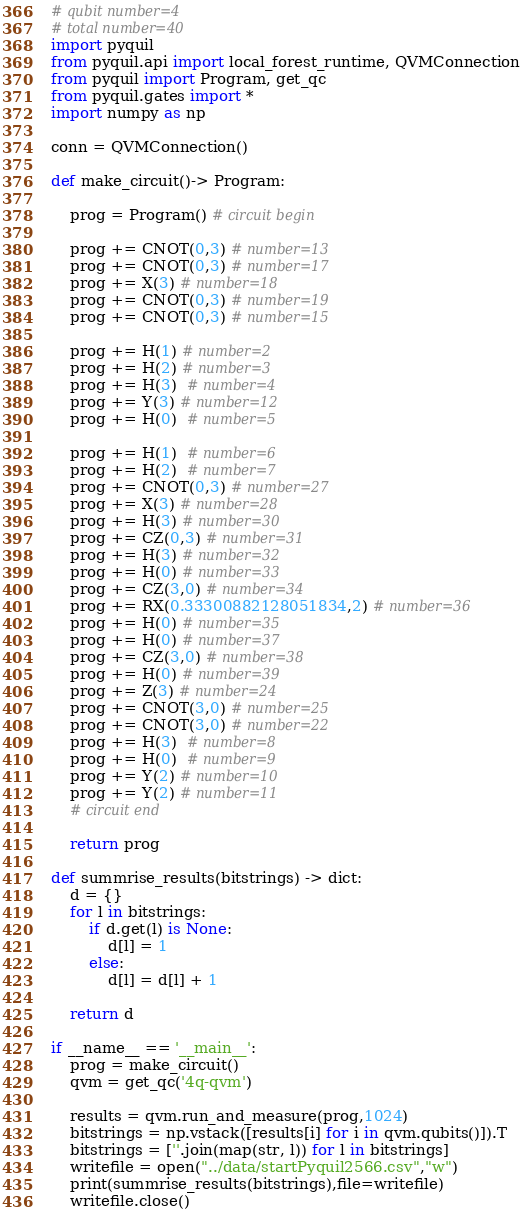<code> <loc_0><loc_0><loc_500><loc_500><_Python_># qubit number=4
# total number=40
import pyquil
from pyquil.api import local_forest_runtime, QVMConnection
from pyquil import Program, get_qc
from pyquil.gates import *
import numpy as np

conn = QVMConnection()

def make_circuit()-> Program:

    prog = Program() # circuit begin

    prog += CNOT(0,3) # number=13
    prog += CNOT(0,3) # number=17
    prog += X(3) # number=18
    prog += CNOT(0,3) # number=19
    prog += CNOT(0,3) # number=15

    prog += H(1) # number=2
    prog += H(2) # number=3
    prog += H(3)  # number=4
    prog += Y(3) # number=12
    prog += H(0)  # number=5

    prog += H(1)  # number=6
    prog += H(2)  # number=7
    prog += CNOT(0,3) # number=27
    prog += X(3) # number=28
    prog += H(3) # number=30
    prog += CZ(0,3) # number=31
    prog += H(3) # number=32
    prog += H(0) # number=33
    prog += CZ(3,0) # number=34
    prog += RX(0.33300882128051834,2) # number=36
    prog += H(0) # number=35
    prog += H(0) # number=37
    prog += CZ(3,0) # number=38
    prog += H(0) # number=39
    prog += Z(3) # number=24
    prog += CNOT(3,0) # number=25
    prog += CNOT(3,0) # number=22
    prog += H(3)  # number=8
    prog += H(0)  # number=9
    prog += Y(2) # number=10
    prog += Y(2) # number=11
    # circuit end

    return prog

def summrise_results(bitstrings) -> dict:
    d = {}
    for l in bitstrings:
        if d.get(l) is None:
            d[l] = 1
        else:
            d[l] = d[l] + 1

    return d

if __name__ == '__main__':
    prog = make_circuit()
    qvm = get_qc('4q-qvm')

    results = qvm.run_and_measure(prog,1024)
    bitstrings = np.vstack([results[i] for i in qvm.qubits()]).T
    bitstrings = [''.join(map(str, l)) for l in bitstrings]
    writefile = open("../data/startPyquil2566.csv","w")
    print(summrise_results(bitstrings),file=writefile)
    writefile.close()

</code> 